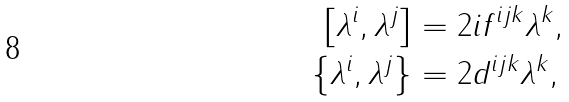<formula> <loc_0><loc_0><loc_500><loc_500>\left [ \lambda ^ { i } , \lambda ^ { j } \right ] & = 2 i f ^ { i j k } \lambda ^ { k } , \\ \left \{ \lambda ^ { i } , \lambda ^ { j } \right \} & = 2 d ^ { i j k } \lambda ^ { k } ,</formula> 